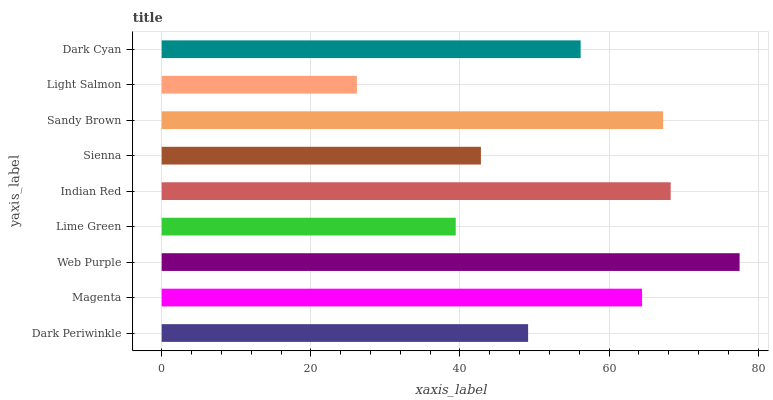Is Light Salmon the minimum?
Answer yes or no. Yes. Is Web Purple the maximum?
Answer yes or no. Yes. Is Magenta the minimum?
Answer yes or no. No. Is Magenta the maximum?
Answer yes or no. No. Is Magenta greater than Dark Periwinkle?
Answer yes or no. Yes. Is Dark Periwinkle less than Magenta?
Answer yes or no. Yes. Is Dark Periwinkle greater than Magenta?
Answer yes or no. No. Is Magenta less than Dark Periwinkle?
Answer yes or no. No. Is Dark Cyan the high median?
Answer yes or no. Yes. Is Dark Cyan the low median?
Answer yes or no. Yes. Is Indian Red the high median?
Answer yes or no. No. Is Indian Red the low median?
Answer yes or no. No. 